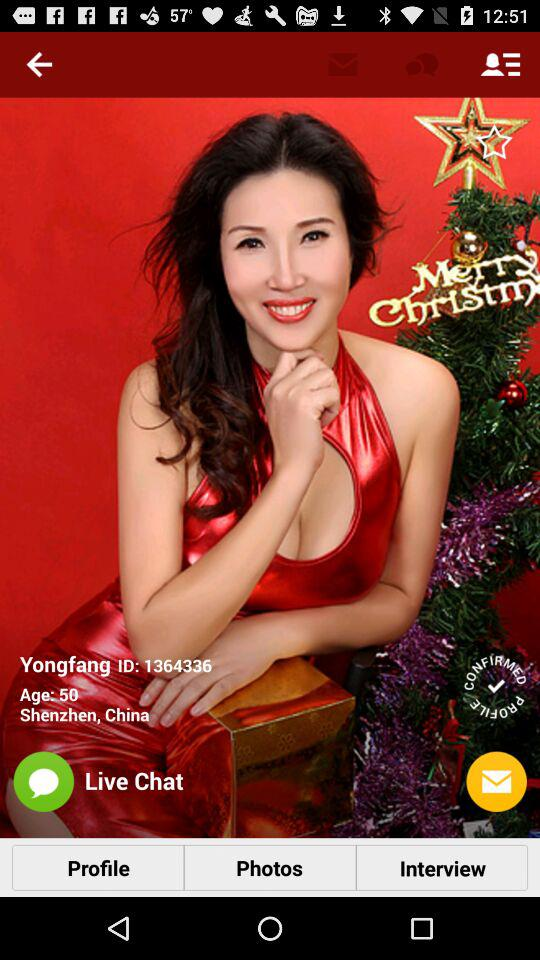What is the given ID? The given ID is 1364336. 